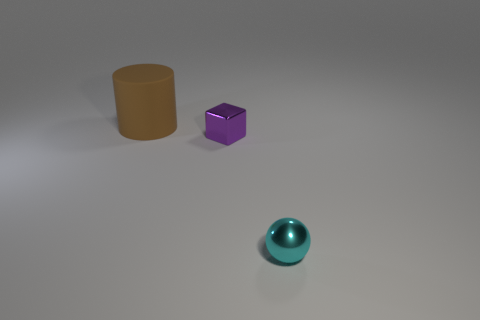What material is the object that is the same size as the purple cube?
Your answer should be very brief. Metal. What is the color of the metal object right of the metal cube?
Offer a terse response. Cyan. How many green balls are there?
Your answer should be compact. 0. Is there a big brown matte cylinder that is in front of the purple shiny block that is left of the tiny object in front of the small purple block?
Offer a very short reply. No. What is the shape of the object that is the same size as the cyan ball?
Your answer should be compact. Cube. What is the material of the tiny block?
Keep it short and to the point. Metal. What number of other things are the same material as the sphere?
Offer a terse response. 1. There is a thing that is left of the cyan metallic object and in front of the large matte thing; what is its size?
Ensure brevity in your answer.  Small. What shape is the thing in front of the metallic thing that is behind the cyan shiny ball?
Make the answer very short. Sphere. Is there anything else that has the same shape as the big matte thing?
Make the answer very short. No. 